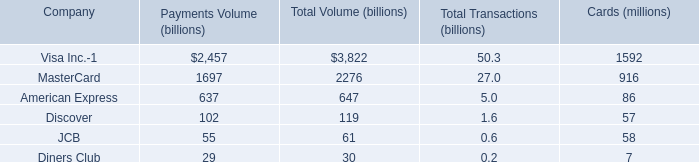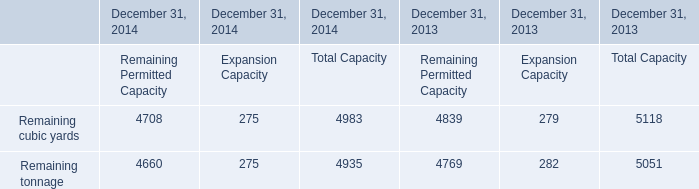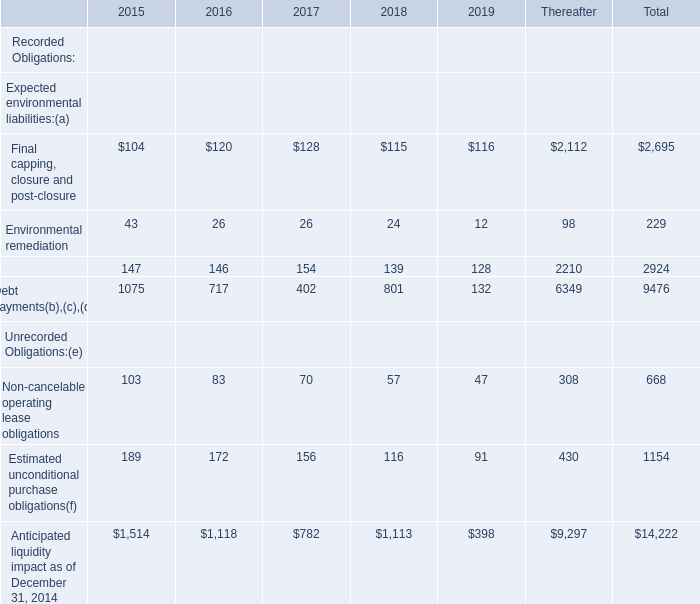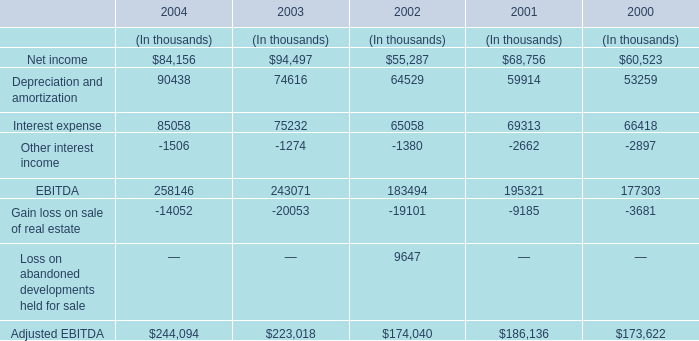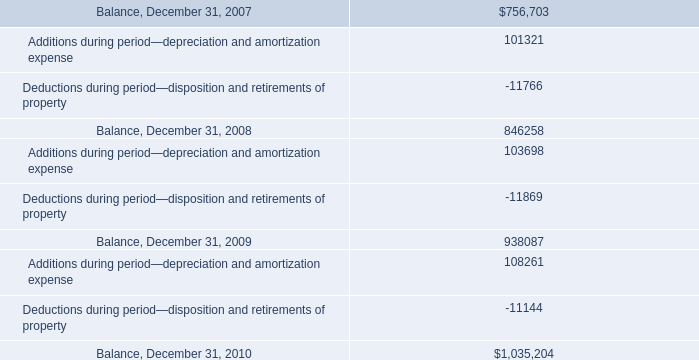Among 2017,2018 and 2019,for which year is Anticipated liquidity impact as of December 31, 2014 the largest? 
Answer: 2018. 